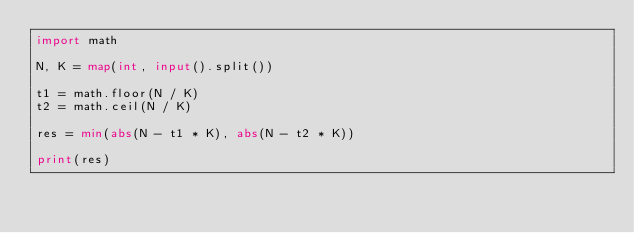<code> <loc_0><loc_0><loc_500><loc_500><_Python_>import math

N, K = map(int, input().split())

t1 = math.floor(N / K)
t2 = math.ceil(N / K)

res = min(abs(N - t1 * K), abs(N - t2 * K))

print(res)</code> 